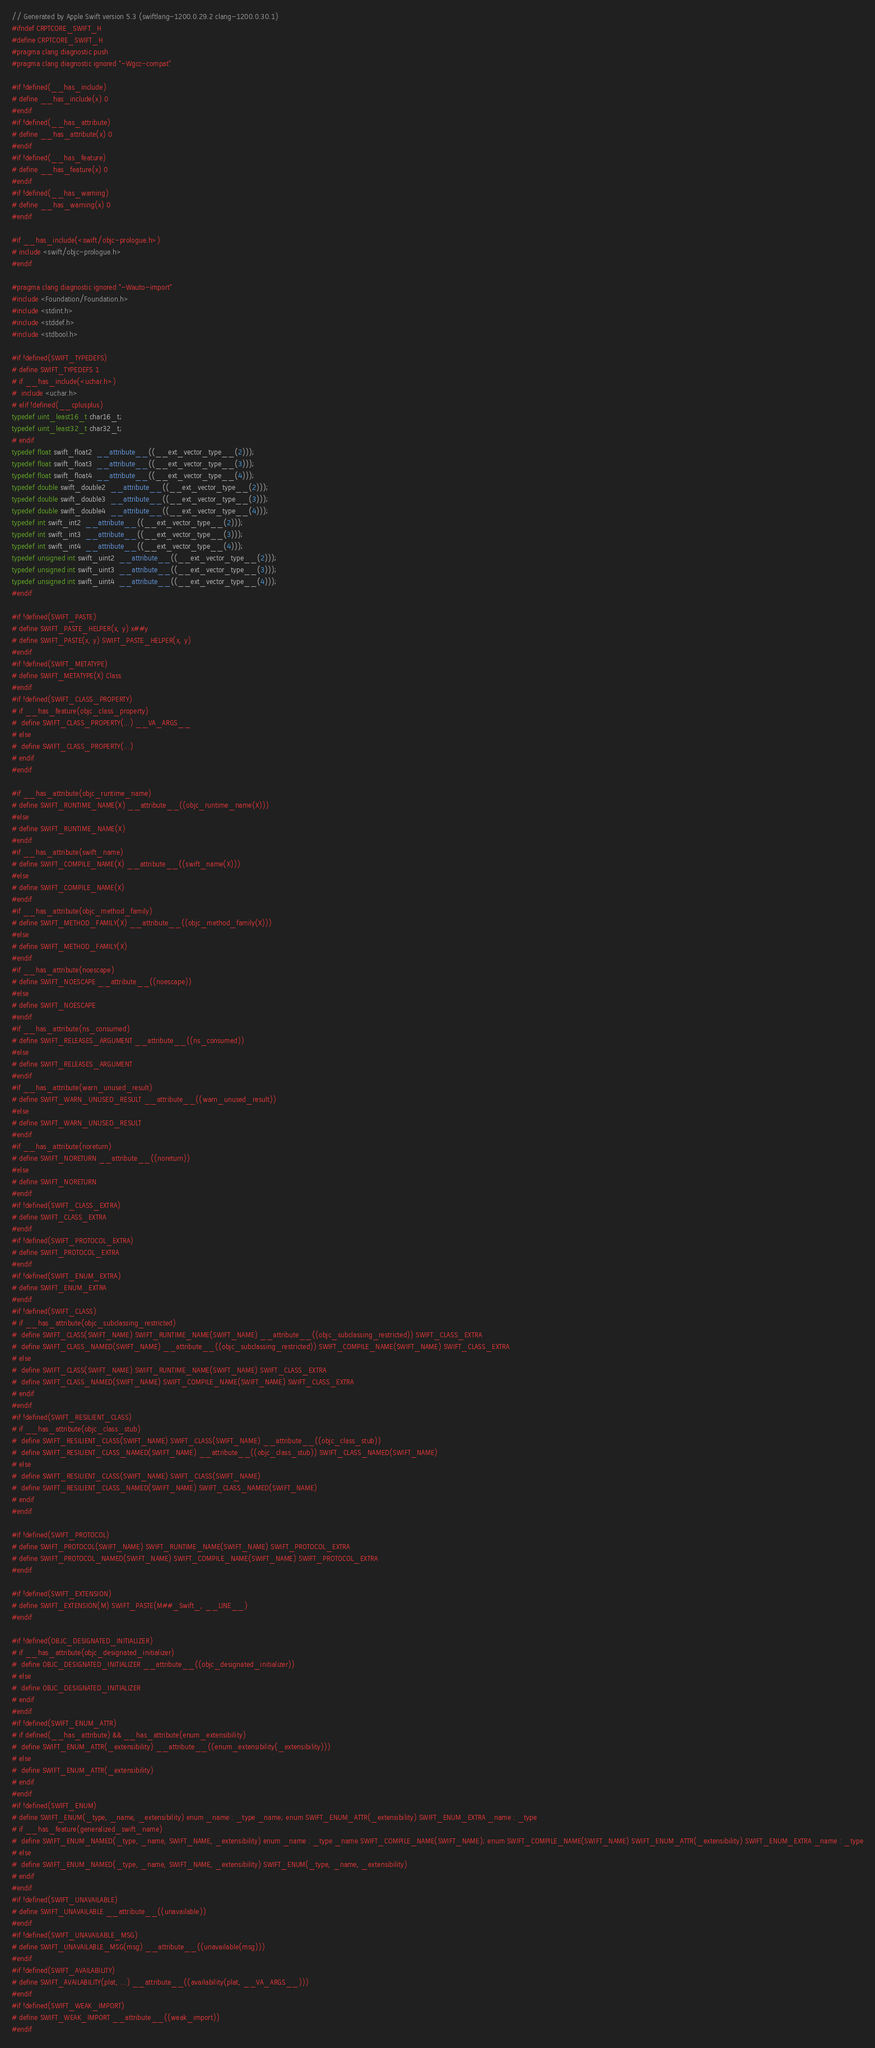<code> <loc_0><loc_0><loc_500><loc_500><_C_>// Generated by Apple Swift version 5.3 (swiftlang-1200.0.29.2 clang-1200.0.30.1)
#ifndef CRPTCORE_SWIFT_H
#define CRPTCORE_SWIFT_H
#pragma clang diagnostic push
#pragma clang diagnostic ignored "-Wgcc-compat"

#if !defined(__has_include)
# define __has_include(x) 0
#endif
#if !defined(__has_attribute)
# define __has_attribute(x) 0
#endif
#if !defined(__has_feature)
# define __has_feature(x) 0
#endif
#if !defined(__has_warning)
# define __has_warning(x) 0
#endif

#if __has_include(<swift/objc-prologue.h>)
# include <swift/objc-prologue.h>
#endif

#pragma clang diagnostic ignored "-Wauto-import"
#include <Foundation/Foundation.h>
#include <stdint.h>
#include <stddef.h>
#include <stdbool.h>

#if !defined(SWIFT_TYPEDEFS)
# define SWIFT_TYPEDEFS 1
# if __has_include(<uchar.h>)
#  include <uchar.h>
# elif !defined(__cplusplus)
typedef uint_least16_t char16_t;
typedef uint_least32_t char32_t;
# endif
typedef float swift_float2  __attribute__((__ext_vector_type__(2)));
typedef float swift_float3  __attribute__((__ext_vector_type__(3)));
typedef float swift_float4  __attribute__((__ext_vector_type__(4)));
typedef double swift_double2  __attribute__((__ext_vector_type__(2)));
typedef double swift_double3  __attribute__((__ext_vector_type__(3)));
typedef double swift_double4  __attribute__((__ext_vector_type__(4)));
typedef int swift_int2  __attribute__((__ext_vector_type__(2)));
typedef int swift_int3  __attribute__((__ext_vector_type__(3)));
typedef int swift_int4  __attribute__((__ext_vector_type__(4)));
typedef unsigned int swift_uint2  __attribute__((__ext_vector_type__(2)));
typedef unsigned int swift_uint3  __attribute__((__ext_vector_type__(3)));
typedef unsigned int swift_uint4  __attribute__((__ext_vector_type__(4)));
#endif

#if !defined(SWIFT_PASTE)
# define SWIFT_PASTE_HELPER(x, y) x##y
# define SWIFT_PASTE(x, y) SWIFT_PASTE_HELPER(x, y)
#endif
#if !defined(SWIFT_METATYPE)
# define SWIFT_METATYPE(X) Class
#endif
#if !defined(SWIFT_CLASS_PROPERTY)
# if __has_feature(objc_class_property)
#  define SWIFT_CLASS_PROPERTY(...) __VA_ARGS__
# else
#  define SWIFT_CLASS_PROPERTY(...)
# endif
#endif

#if __has_attribute(objc_runtime_name)
# define SWIFT_RUNTIME_NAME(X) __attribute__((objc_runtime_name(X)))
#else
# define SWIFT_RUNTIME_NAME(X)
#endif
#if __has_attribute(swift_name)
# define SWIFT_COMPILE_NAME(X) __attribute__((swift_name(X)))
#else
# define SWIFT_COMPILE_NAME(X)
#endif
#if __has_attribute(objc_method_family)
# define SWIFT_METHOD_FAMILY(X) __attribute__((objc_method_family(X)))
#else
# define SWIFT_METHOD_FAMILY(X)
#endif
#if __has_attribute(noescape)
# define SWIFT_NOESCAPE __attribute__((noescape))
#else
# define SWIFT_NOESCAPE
#endif
#if __has_attribute(ns_consumed)
# define SWIFT_RELEASES_ARGUMENT __attribute__((ns_consumed))
#else
# define SWIFT_RELEASES_ARGUMENT
#endif
#if __has_attribute(warn_unused_result)
# define SWIFT_WARN_UNUSED_RESULT __attribute__((warn_unused_result))
#else
# define SWIFT_WARN_UNUSED_RESULT
#endif
#if __has_attribute(noreturn)
# define SWIFT_NORETURN __attribute__((noreturn))
#else
# define SWIFT_NORETURN
#endif
#if !defined(SWIFT_CLASS_EXTRA)
# define SWIFT_CLASS_EXTRA
#endif
#if !defined(SWIFT_PROTOCOL_EXTRA)
# define SWIFT_PROTOCOL_EXTRA
#endif
#if !defined(SWIFT_ENUM_EXTRA)
# define SWIFT_ENUM_EXTRA
#endif
#if !defined(SWIFT_CLASS)
# if __has_attribute(objc_subclassing_restricted)
#  define SWIFT_CLASS(SWIFT_NAME) SWIFT_RUNTIME_NAME(SWIFT_NAME) __attribute__((objc_subclassing_restricted)) SWIFT_CLASS_EXTRA
#  define SWIFT_CLASS_NAMED(SWIFT_NAME) __attribute__((objc_subclassing_restricted)) SWIFT_COMPILE_NAME(SWIFT_NAME) SWIFT_CLASS_EXTRA
# else
#  define SWIFT_CLASS(SWIFT_NAME) SWIFT_RUNTIME_NAME(SWIFT_NAME) SWIFT_CLASS_EXTRA
#  define SWIFT_CLASS_NAMED(SWIFT_NAME) SWIFT_COMPILE_NAME(SWIFT_NAME) SWIFT_CLASS_EXTRA
# endif
#endif
#if !defined(SWIFT_RESILIENT_CLASS)
# if __has_attribute(objc_class_stub)
#  define SWIFT_RESILIENT_CLASS(SWIFT_NAME) SWIFT_CLASS(SWIFT_NAME) __attribute__((objc_class_stub))
#  define SWIFT_RESILIENT_CLASS_NAMED(SWIFT_NAME) __attribute__((objc_class_stub)) SWIFT_CLASS_NAMED(SWIFT_NAME)
# else
#  define SWIFT_RESILIENT_CLASS(SWIFT_NAME) SWIFT_CLASS(SWIFT_NAME)
#  define SWIFT_RESILIENT_CLASS_NAMED(SWIFT_NAME) SWIFT_CLASS_NAMED(SWIFT_NAME)
# endif
#endif

#if !defined(SWIFT_PROTOCOL)
# define SWIFT_PROTOCOL(SWIFT_NAME) SWIFT_RUNTIME_NAME(SWIFT_NAME) SWIFT_PROTOCOL_EXTRA
# define SWIFT_PROTOCOL_NAMED(SWIFT_NAME) SWIFT_COMPILE_NAME(SWIFT_NAME) SWIFT_PROTOCOL_EXTRA
#endif

#if !defined(SWIFT_EXTENSION)
# define SWIFT_EXTENSION(M) SWIFT_PASTE(M##_Swift_, __LINE__)
#endif

#if !defined(OBJC_DESIGNATED_INITIALIZER)
# if __has_attribute(objc_designated_initializer)
#  define OBJC_DESIGNATED_INITIALIZER __attribute__((objc_designated_initializer))
# else
#  define OBJC_DESIGNATED_INITIALIZER
# endif
#endif
#if !defined(SWIFT_ENUM_ATTR)
# if defined(__has_attribute) && __has_attribute(enum_extensibility)
#  define SWIFT_ENUM_ATTR(_extensibility) __attribute__((enum_extensibility(_extensibility)))
# else
#  define SWIFT_ENUM_ATTR(_extensibility)
# endif
#endif
#if !defined(SWIFT_ENUM)
# define SWIFT_ENUM(_type, _name, _extensibility) enum _name : _type _name; enum SWIFT_ENUM_ATTR(_extensibility) SWIFT_ENUM_EXTRA _name : _type
# if __has_feature(generalized_swift_name)
#  define SWIFT_ENUM_NAMED(_type, _name, SWIFT_NAME, _extensibility) enum _name : _type _name SWIFT_COMPILE_NAME(SWIFT_NAME); enum SWIFT_COMPILE_NAME(SWIFT_NAME) SWIFT_ENUM_ATTR(_extensibility) SWIFT_ENUM_EXTRA _name : _type
# else
#  define SWIFT_ENUM_NAMED(_type, _name, SWIFT_NAME, _extensibility) SWIFT_ENUM(_type, _name, _extensibility)
# endif
#endif
#if !defined(SWIFT_UNAVAILABLE)
# define SWIFT_UNAVAILABLE __attribute__((unavailable))
#endif
#if !defined(SWIFT_UNAVAILABLE_MSG)
# define SWIFT_UNAVAILABLE_MSG(msg) __attribute__((unavailable(msg)))
#endif
#if !defined(SWIFT_AVAILABILITY)
# define SWIFT_AVAILABILITY(plat, ...) __attribute__((availability(plat, __VA_ARGS__)))
#endif
#if !defined(SWIFT_WEAK_IMPORT)
# define SWIFT_WEAK_IMPORT __attribute__((weak_import))
#endif</code> 